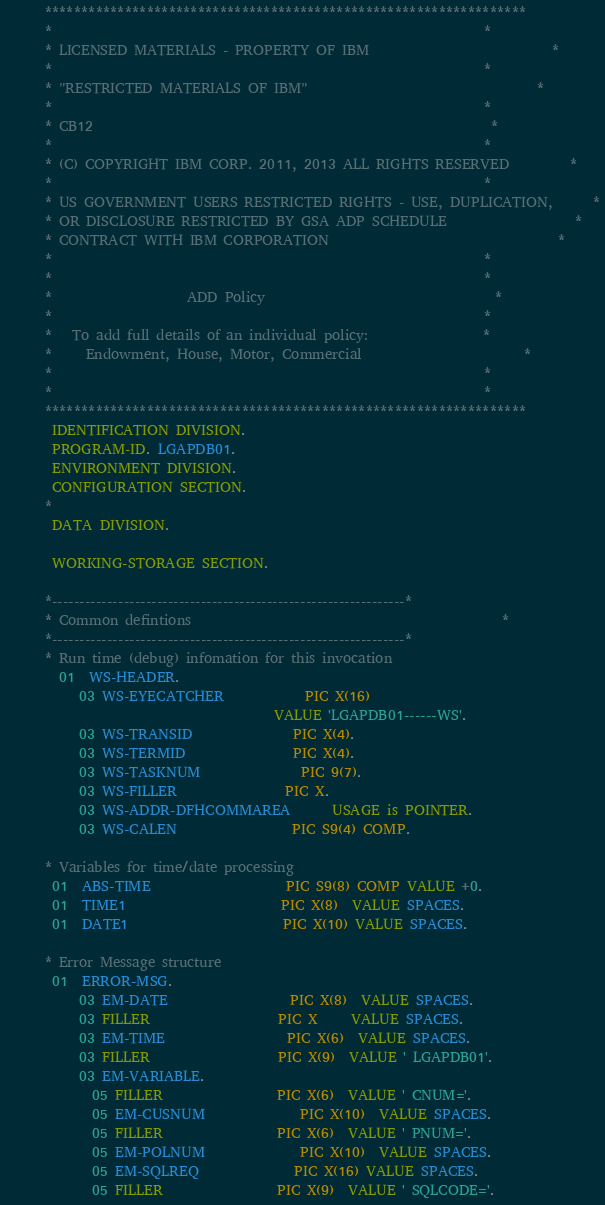Convert code to text. <code><loc_0><loc_0><loc_500><loc_500><_COBOL_>      ******************************************************************
      *                                                                *
      * LICENSED MATERIALS - PROPERTY OF IBM                           *
      *                                                                *
      * "RESTRICTED MATERIALS OF IBM"                                  *
      *                                                                *
      * CB12                                                           *
      *                                                                *
      * (C) COPYRIGHT IBM CORP. 2011, 2013 ALL RIGHTS RESERVED         *
      *                                                                *
      * US GOVERNMENT USERS RESTRICTED RIGHTS - USE, DUPLICATION,      *
      * OR DISCLOSURE RESTRICTED BY GSA ADP SCHEDULE                   *
      * CONTRACT WITH IBM CORPORATION                                  *
      *                                                                *
      *                                                                *
      *                    ADD Policy                                  *
      *                                                                *
      *   To add full details of an individual policy:                 *
      *     Endowment, House, Motor, Commercial                        *
      *                                                                *
      *                                                                *
      ******************************************************************
       IDENTIFICATION DIVISION.
       PROGRAM-ID. LGAPDB01.
       ENVIRONMENT DIVISION.
       CONFIGURATION SECTION.
      *
       DATA DIVISION.

       WORKING-STORAGE SECTION.

      *----------------------------------------------------------------*
      * Common defintions                                              *
      *----------------------------------------------------------------*
      * Run time (debug) infomation for this invocation
        01  WS-HEADER.
           03 WS-EYECATCHER            PIC X(16)
                                        VALUE 'LGAPDB01------WS'.
           03 WS-TRANSID               PIC X(4).
           03 WS-TERMID                PIC X(4).
           03 WS-TASKNUM               PIC 9(7).
           03 WS-FILLER                PIC X.
           03 WS-ADDR-DFHCOMMAREA      USAGE is POINTER.
           03 WS-CALEN                 PIC S9(4) COMP.

      * Variables for time/date processing
       01  ABS-TIME                    PIC S9(8) COMP VALUE +0.
       01  TIME1                       PIC X(8)  VALUE SPACES.
       01  DATE1                       PIC X(10) VALUE SPACES.

      * Error Message structure
       01  ERROR-MSG.
           03 EM-DATE                  PIC X(8)  VALUE SPACES.
           03 FILLER                   PIC X     VALUE SPACES.
           03 EM-TIME                  PIC X(6)  VALUE SPACES.
           03 FILLER                   PIC X(9)  VALUE ' LGAPDB01'.
           03 EM-VARIABLE.
             05 FILLER                 PIC X(6)  VALUE ' CNUM='.
             05 EM-CUSNUM              PIC X(10)  VALUE SPACES.
             05 FILLER                 PIC X(6)  VALUE ' PNUM='.
             05 EM-POLNUM              PIC X(10)  VALUE SPACES.
             05 EM-SQLREQ              PIC X(16) VALUE SPACES.
             05 FILLER                 PIC X(9)  VALUE ' SQLCODE='.</code> 